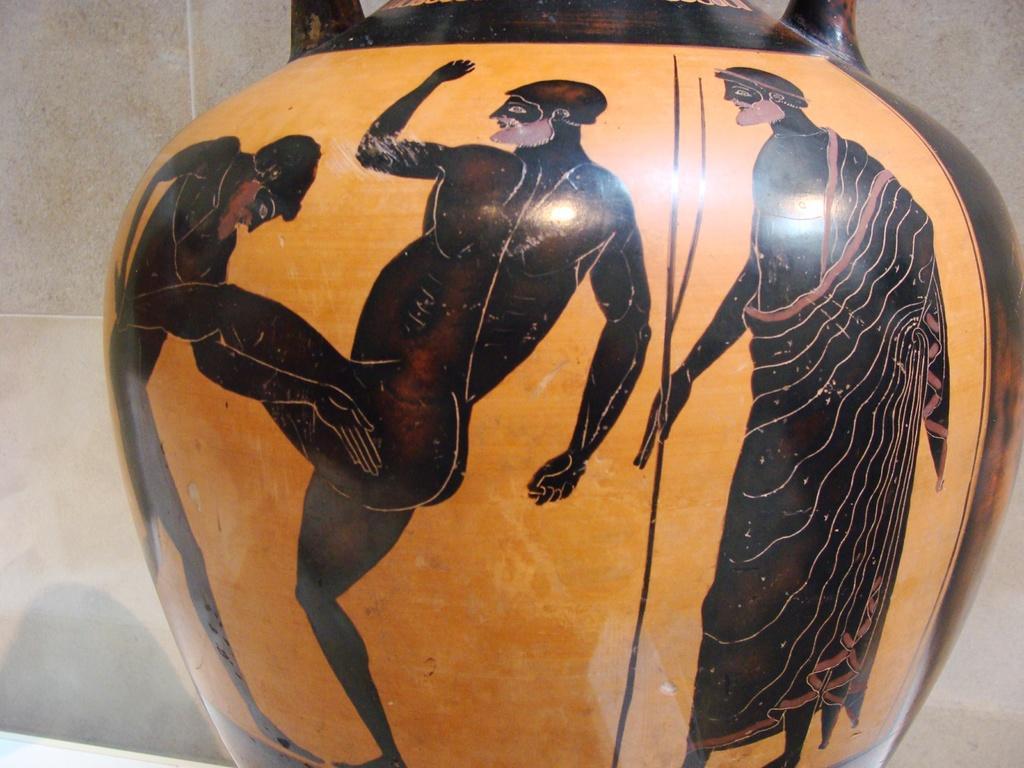Please provide a concise description of this image. In the image in the center we can see one pot,which is in black and yellow color. On the pot,we can see three human images. In the background there is a wall. 